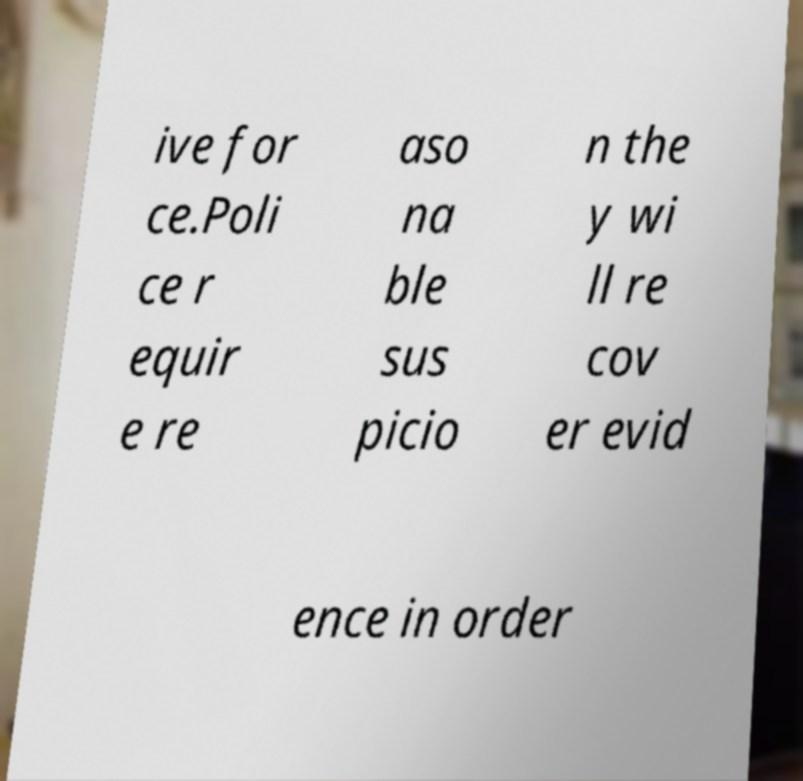What messages or text are displayed in this image? I need them in a readable, typed format. ive for ce.Poli ce r equir e re aso na ble sus picio n the y wi ll re cov er evid ence in order 